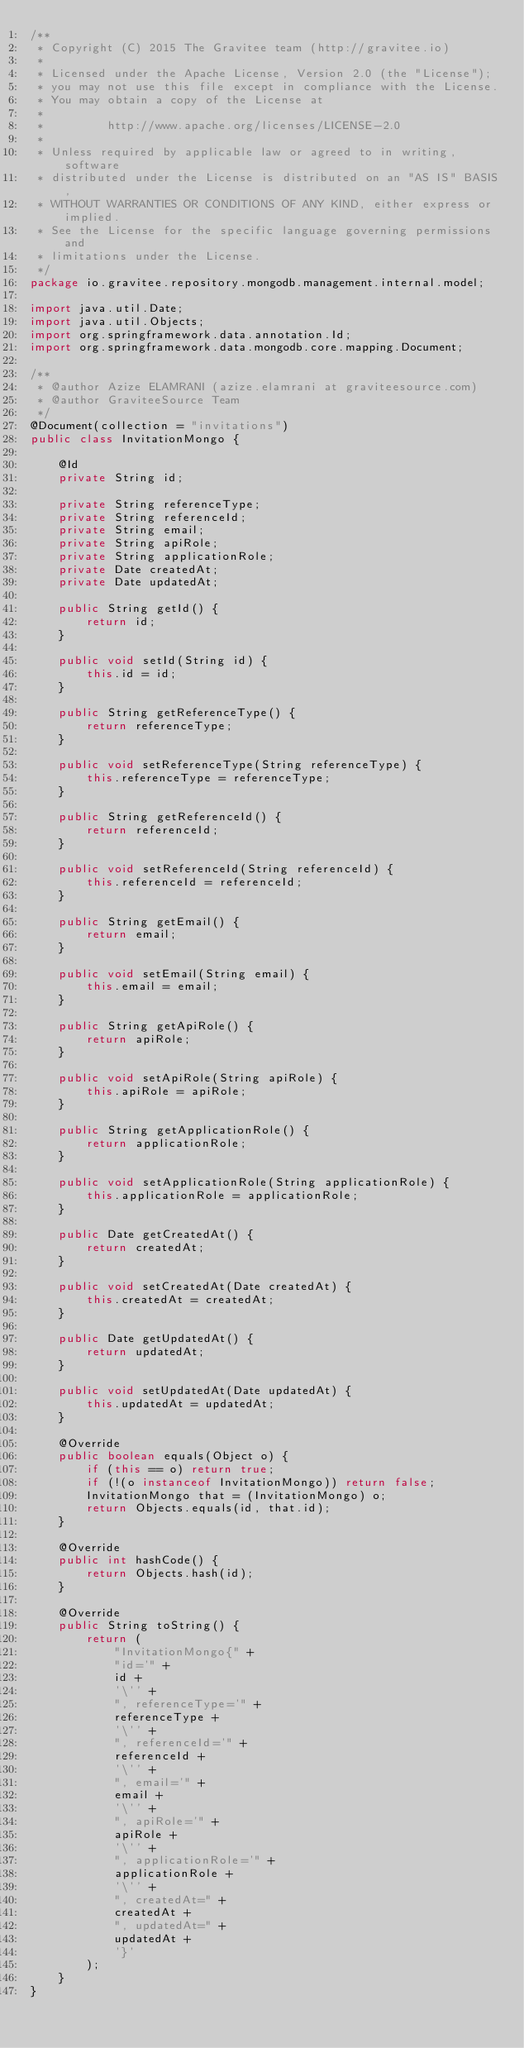Convert code to text. <code><loc_0><loc_0><loc_500><loc_500><_Java_>/**
 * Copyright (C) 2015 The Gravitee team (http://gravitee.io)
 *
 * Licensed under the Apache License, Version 2.0 (the "License");
 * you may not use this file except in compliance with the License.
 * You may obtain a copy of the License at
 *
 *         http://www.apache.org/licenses/LICENSE-2.0
 *
 * Unless required by applicable law or agreed to in writing, software
 * distributed under the License is distributed on an "AS IS" BASIS,
 * WITHOUT WARRANTIES OR CONDITIONS OF ANY KIND, either express or implied.
 * See the License for the specific language governing permissions and
 * limitations under the License.
 */
package io.gravitee.repository.mongodb.management.internal.model;

import java.util.Date;
import java.util.Objects;
import org.springframework.data.annotation.Id;
import org.springframework.data.mongodb.core.mapping.Document;

/**
 * @author Azize ELAMRANI (azize.elamrani at graviteesource.com)
 * @author GraviteeSource Team
 */
@Document(collection = "invitations")
public class InvitationMongo {

    @Id
    private String id;

    private String referenceType;
    private String referenceId;
    private String email;
    private String apiRole;
    private String applicationRole;
    private Date createdAt;
    private Date updatedAt;

    public String getId() {
        return id;
    }

    public void setId(String id) {
        this.id = id;
    }

    public String getReferenceType() {
        return referenceType;
    }

    public void setReferenceType(String referenceType) {
        this.referenceType = referenceType;
    }

    public String getReferenceId() {
        return referenceId;
    }

    public void setReferenceId(String referenceId) {
        this.referenceId = referenceId;
    }

    public String getEmail() {
        return email;
    }

    public void setEmail(String email) {
        this.email = email;
    }

    public String getApiRole() {
        return apiRole;
    }

    public void setApiRole(String apiRole) {
        this.apiRole = apiRole;
    }

    public String getApplicationRole() {
        return applicationRole;
    }

    public void setApplicationRole(String applicationRole) {
        this.applicationRole = applicationRole;
    }

    public Date getCreatedAt() {
        return createdAt;
    }

    public void setCreatedAt(Date createdAt) {
        this.createdAt = createdAt;
    }

    public Date getUpdatedAt() {
        return updatedAt;
    }

    public void setUpdatedAt(Date updatedAt) {
        this.updatedAt = updatedAt;
    }

    @Override
    public boolean equals(Object o) {
        if (this == o) return true;
        if (!(o instanceof InvitationMongo)) return false;
        InvitationMongo that = (InvitationMongo) o;
        return Objects.equals(id, that.id);
    }

    @Override
    public int hashCode() {
        return Objects.hash(id);
    }

    @Override
    public String toString() {
        return (
            "InvitationMongo{" +
            "id='" +
            id +
            '\'' +
            ", referenceType='" +
            referenceType +
            '\'' +
            ", referenceId='" +
            referenceId +
            '\'' +
            ", email='" +
            email +
            '\'' +
            ", apiRole='" +
            apiRole +
            '\'' +
            ", applicationRole='" +
            applicationRole +
            '\'' +
            ", createdAt=" +
            createdAt +
            ", updatedAt=" +
            updatedAt +
            '}'
        );
    }
}
</code> 